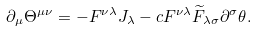<formula> <loc_0><loc_0><loc_500><loc_500>\partial _ { \mu } \Theta ^ { \mu \nu } = - F ^ { \nu \lambda } J _ { \lambda } - c F ^ { \nu \lambda } \widetilde { F } _ { \lambda \sigma } \partial ^ { \sigma } \theta .</formula> 